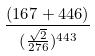<formula> <loc_0><loc_0><loc_500><loc_500>\frac { ( 1 6 7 + 4 4 6 ) } { ( \frac { \sqrt { 2 } } { 2 7 6 } ) ^ { 4 4 3 } }</formula> 